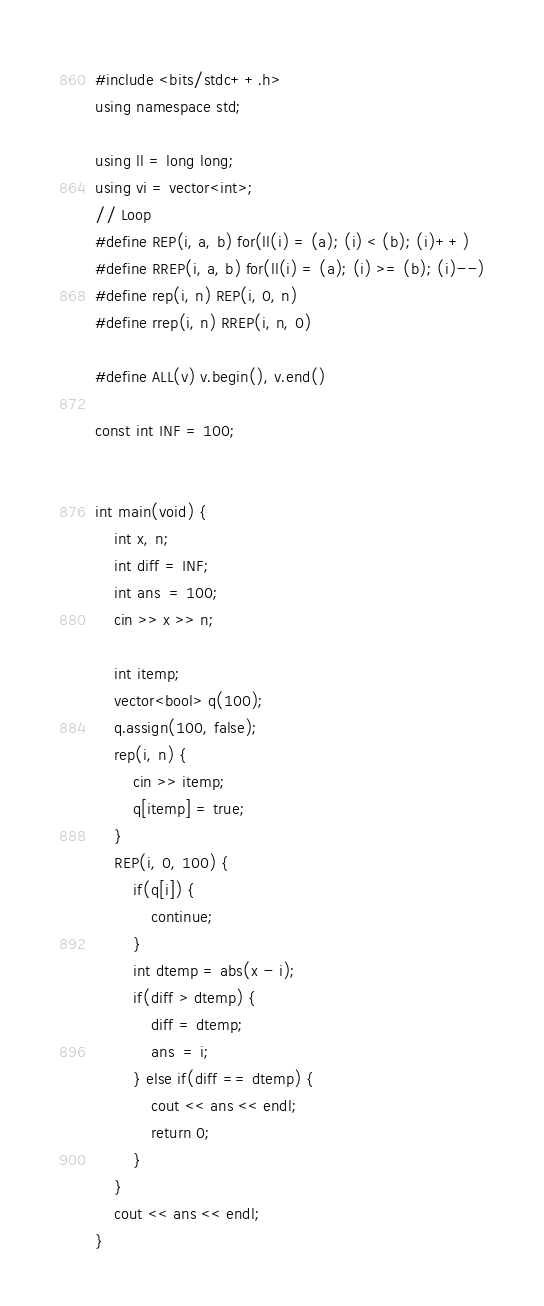Convert code to text. <code><loc_0><loc_0><loc_500><loc_500><_C++_>#include <bits/stdc++.h>
using namespace std;

using ll = long long;
using vi = vector<int>;
// Loop
#define REP(i, a, b) for(ll(i) = (a); (i) < (b); (i)++)
#define RREP(i, a, b) for(ll(i) = (a); (i) >= (b); (i)--)
#define rep(i, n) REP(i, 0, n)
#define rrep(i, n) RREP(i, n, 0)

#define ALL(v) v.begin(), v.end()

const int INF = 100;


int main(void) {
	int x, n;
	int diff = INF;
	int ans  = 100;
	cin >> x >> n;

	int itemp;
	vector<bool> q(100);
	q.assign(100, false);
	rep(i, n) {
		cin >> itemp;
		q[itemp] = true;
	}
	REP(i, 0, 100) {
		if(q[i]) {
			continue;
		}
		int dtemp = abs(x - i);
		if(diff > dtemp) {
			diff = dtemp;
			ans  = i;
		} else if(diff == dtemp) {
			cout << ans << endl;
			return 0;
		}
	}
	cout << ans << endl;
}</code> 